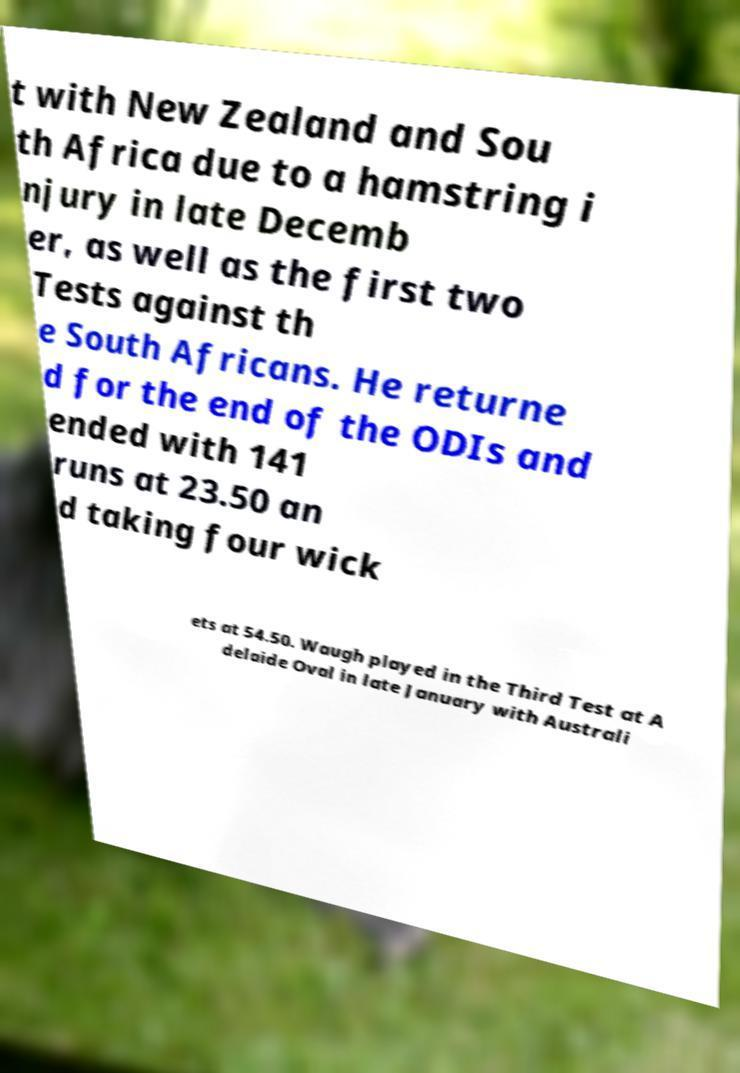What messages or text are displayed in this image? I need them in a readable, typed format. t with New Zealand and Sou th Africa due to a hamstring i njury in late Decemb er, as well as the first two Tests against th e South Africans. He returne d for the end of the ODIs and ended with 141 runs at 23.50 an d taking four wick ets at 54.50. Waugh played in the Third Test at A delaide Oval in late January with Australi 